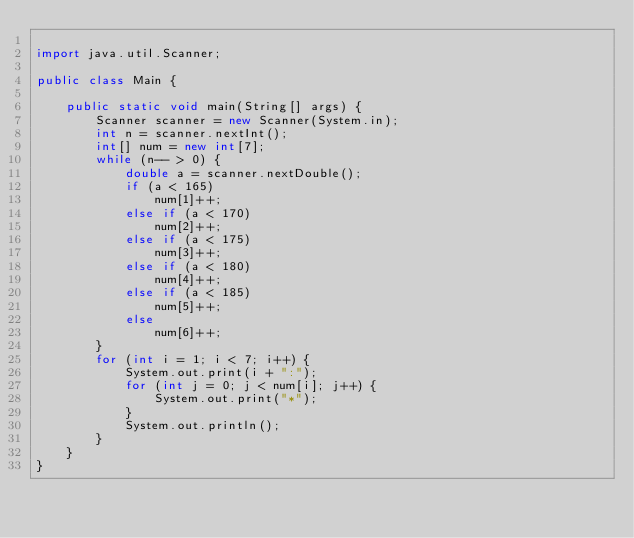Convert code to text. <code><loc_0><loc_0><loc_500><loc_500><_Java_>
import java.util.Scanner;

public class Main {

	public static void main(String[] args) {
		Scanner scanner = new Scanner(System.in);
		int n = scanner.nextInt();
		int[] num = new int[7];
		while (n-- > 0) {
			double a = scanner.nextDouble();
			if (a < 165)
				num[1]++;
			else if (a < 170)
				num[2]++;
			else if (a < 175)
				num[3]++;
			else if (a < 180)
				num[4]++;
			else if (a < 185)
				num[5]++;
			else
				num[6]++;
		}
		for (int i = 1; i < 7; i++) {
			System.out.print(i + ":");
			for (int j = 0; j < num[i]; j++) {
				System.out.print("*");
			}
			System.out.println();
		}
	}
}</code> 